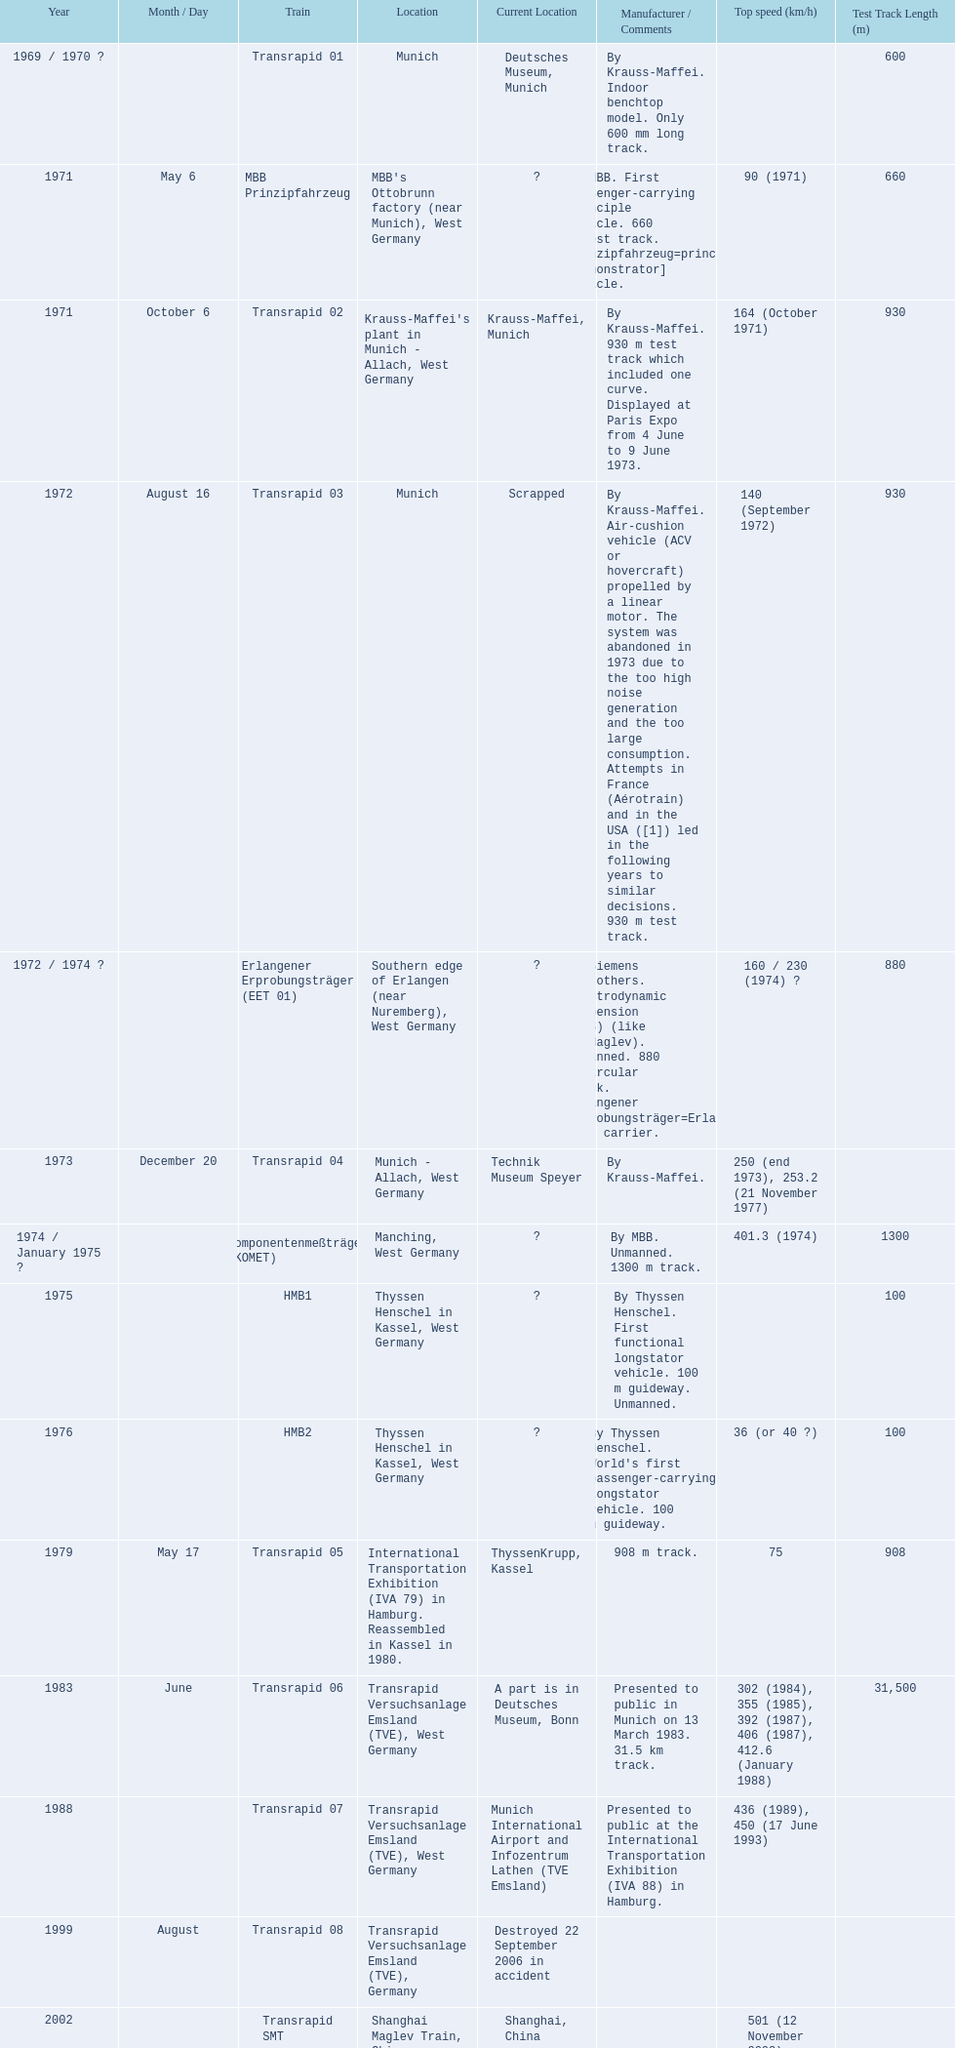What are all trains? Transrapid 01, MBB Prinzipfahrzeug, Transrapid 02, Transrapid 03, Erlangener Erprobungsträger (EET 01), Transrapid 04, Komponentenmeßträger (KOMET), HMB1, HMB2, Transrapid 05, Transrapid 06, Transrapid 07, Transrapid 08, Transrapid SMT, Transrapid 09. Which of all location of trains are known? Deutsches Museum, Munich, Krauss-Maffei, Munich, Scrapped, Technik Museum Speyer, ThyssenKrupp, Kassel, A part is in Deutsches Museum, Bonn, Munich International Airport and Infozentrum Lathen (TVE Emsland), Destroyed 22 September 2006 in accident, Shanghai, China. Which of those trains were scrapped? Transrapid 03. 